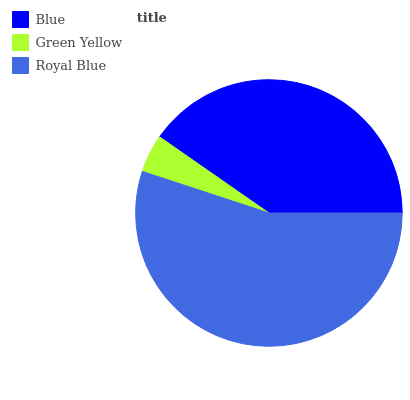Is Green Yellow the minimum?
Answer yes or no. Yes. Is Royal Blue the maximum?
Answer yes or no. Yes. Is Royal Blue the minimum?
Answer yes or no. No. Is Green Yellow the maximum?
Answer yes or no. No. Is Royal Blue greater than Green Yellow?
Answer yes or no. Yes. Is Green Yellow less than Royal Blue?
Answer yes or no. Yes. Is Green Yellow greater than Royal Blue?
Answer yes or no. No. Is Royal Blue less than Green Yellow?
Answer yes or no. No. Is Blue the high median?
Answer yes or no. Yes. Is Blue the low median?
Answer yes or no. Yes. Is Royal Blue the high median?
Answer yes or no. No. Is Green Yellow the low median?
Answer yes or no. No. 